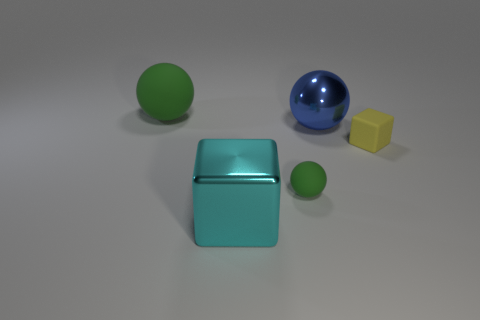Add 3 blue rubber objects. How many objects exist? 8 Subtract all large green balls. How many balls are left? 2 Subtract all cyan cubes. How many cubes are left? 1 Add 3 metallic spheres. How many metallic spheres exist? 4 Subtract 0 blue cylinders. How many objects are left? 5 Subtract all balls. How many objects are left? 2 Subtract 2 blocks. How many blocks are left? 0 Subtract all cyan blocks. Subtract all purple spheres. How many blocks are left? 1 Subtract all gray cylinders. How many green spheres are left? 2 Subtract all cyan rubber cylinders. Subtract all blue spheres. How many objects are left? 4 